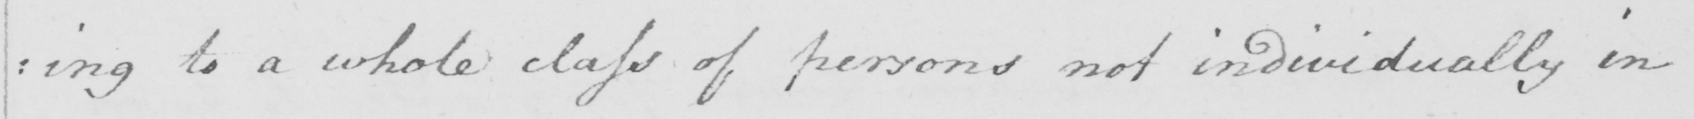Please transcribe the handwritten text in this image. : ing to a whole class of persons not individually in 